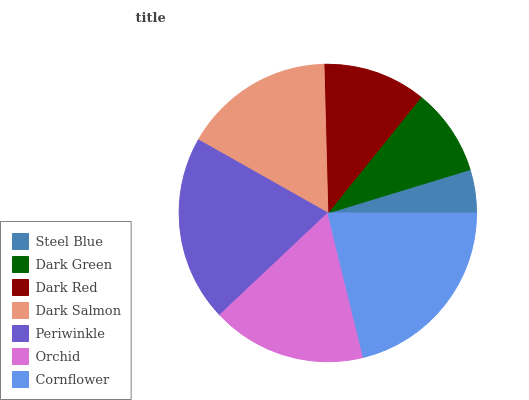Is Steel Blue the minimum?
Answer yes or no. Yes. Is Cornflower the maximum?
Answer yes or no. Yes. Is Dark Green the minimum?
Answer yes or no. No. Is Dark Green the maximum?
Answer yes or no. No. Is Dark Green greater than Steel Blue?
Answer yes or no. Yes. Is Steel Blue less than Dark Green?
Answer yes or no. Yes. Is Steel Blue greater than Dark Green?
Answer yes or no. No. Is Dark Green less than Steel Blue?
Answer yes or no. No. Is Dark Salmon the high median?
Answer yes or no. Yes. Is Dark Salmon the low median?
Answer yes or no. Yes. Is Periwinkle the high median?
Answer yes or no. No. Is Dark Green the low median?
Answer yes or no. No. 